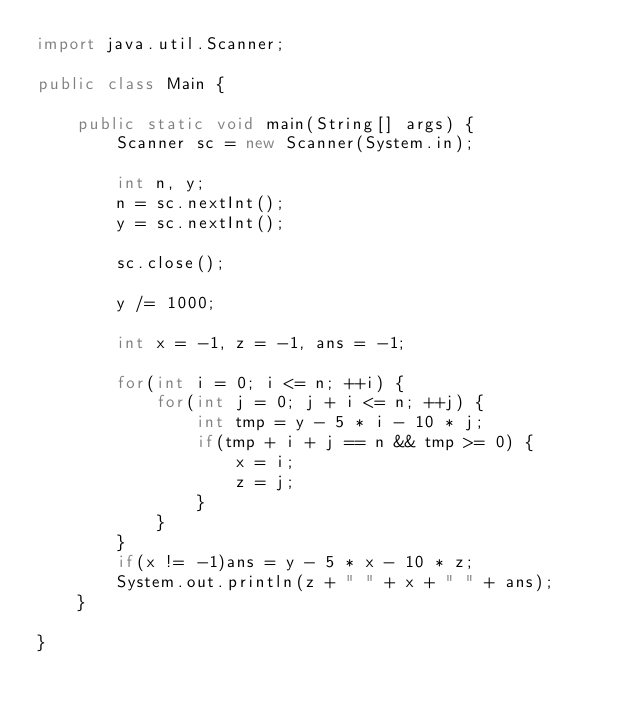Convert code to text. <code><loc_0><loc_0><loc_500><loc_500><_Java_>import java.util.Scanner;

public class Main {

	public static void main(String[] args) {
		Scanner sc = new Scanner(System.in);
		
		int n, y;
		n = sc.nextInt();
		y = sc.nextInt();
		
		sc.close();
		
		y /= 1000;

		int x = -1, z = -1, ans = -1;
		
		for(int i = 0; i <= n; ++i) {
			for(int j = 0; j + i <= n; ++j) {
				int tmp = y - 5 * i - 10 * j;
				if(tmp + i + j == n && tmp >= 0) {
					x = i;
					z = j;
				}
			}
		}
		if(x != -1)ans = y - 5 * x - 10 * z;
		System.out.println(z + " " + x + " " + ans);
	}

}
</code> 